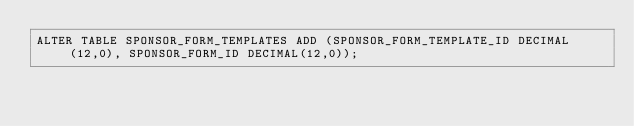Convert code to text. <code><loc_0><loc_0><loc_500><loc_500><_SQL_>ALTER TABLE SPONSOR_FORM_TEMPLATES ADD (SPONSOR_FORM_TEMPLATE_ID DECIMAL(12,0), SPONSOR_FORM_ID DECIMAL(12,0));</code> 